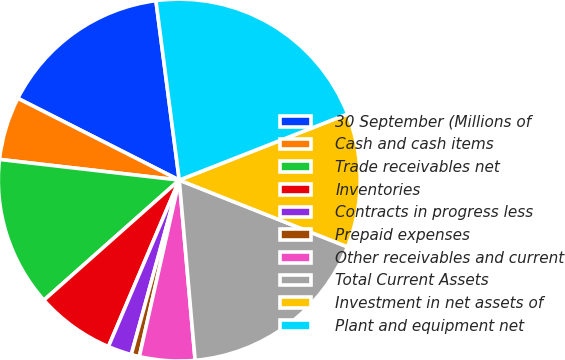Convert chart to OTSL. <chart><loc_0><loc_0><loc_500><loc_500><pie_chart><fcel>30 September (Millions of<fcel>Cash and cash items<fcel>Trade receivables net<fcel>Inventories<fcel>Contracts in progress less<fcel>Prepaid expenses<fcel>Other receivables and current<fcel>Total Current Assets<fcel>Investment in net assets of<fcel>Plant and equipment net<nl><fcel>15.48%<fcel>5.64%<fcel>13.37%<fcel>7.05%<fcel>2.13%<fcel>0.73%<fcel>4.94%<fcel>17.59%<fcel>11.97%<fcel>21.1%<nl></chart> 